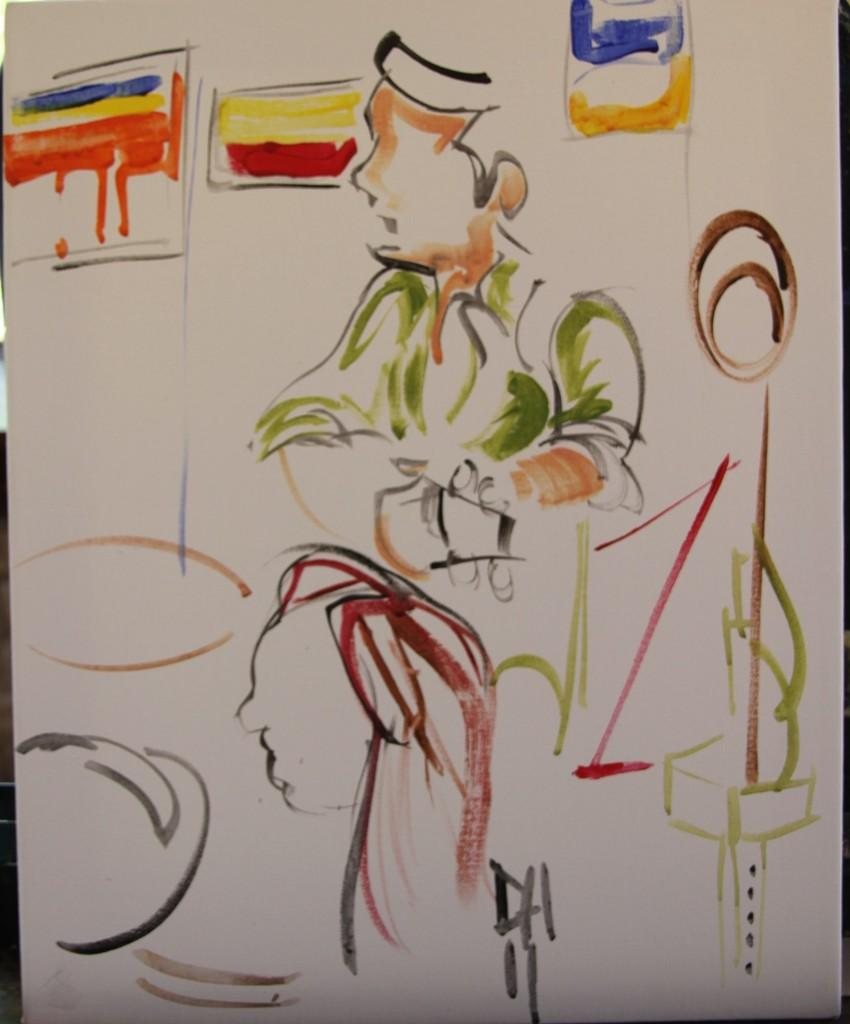What is the medium used to create the image? The image is painted. What type of sweater is the person wearing in the image? There is no person or sweater present in the image, as it is a painted artwork. What type of rice is being cooked in the image? There is no rice or cooking activity depicted in the image, as it is a painted artwork. 